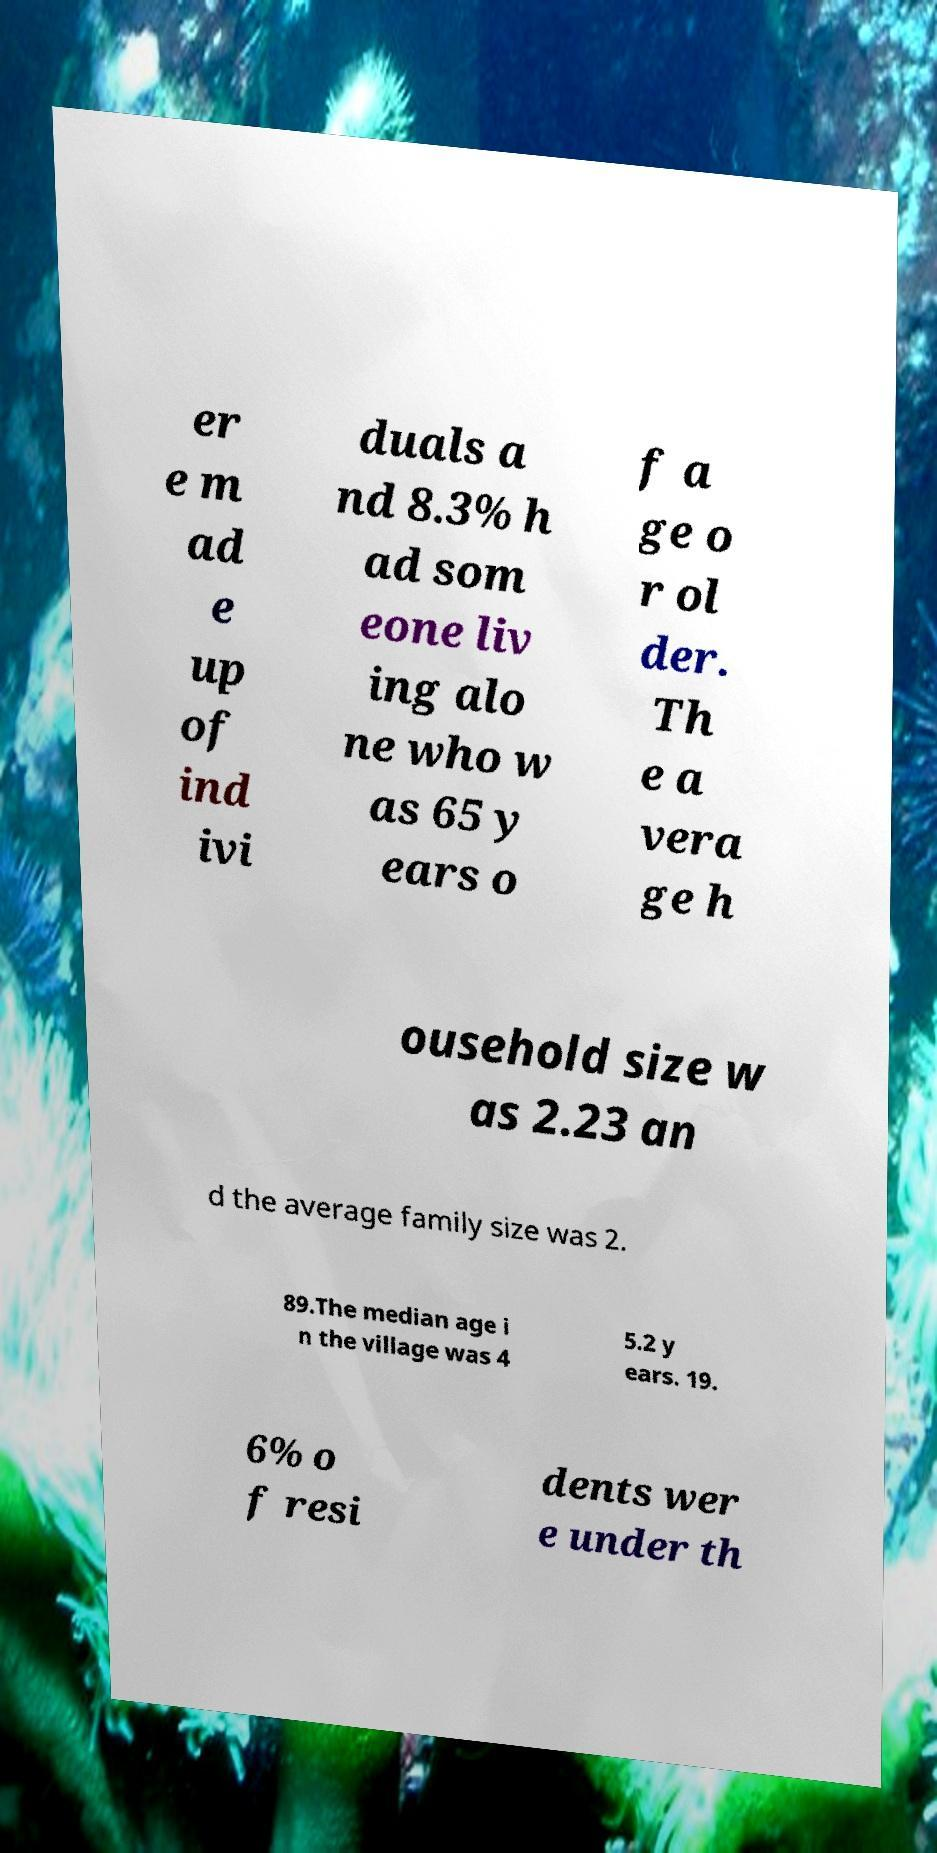Please identify and transcribe the text found in this image. er e m ad e up of ind ivi duals a nd 8.3% h ad som eone liv ing alo ne who w as 65 y ears o f a ge o r ol der. Th e a vera ge h ousehold size w as 2.23 an d the average family size was 2. 89.The median age i n the village was 4 5.2 y ears. 19. 6% o f resi dents wer e under th 